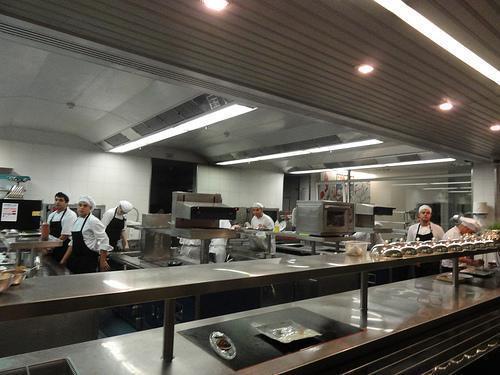How many cooks have no cap?
Give a very brief answer. 1. How many men are there?
Give a very brief answer. 6. 